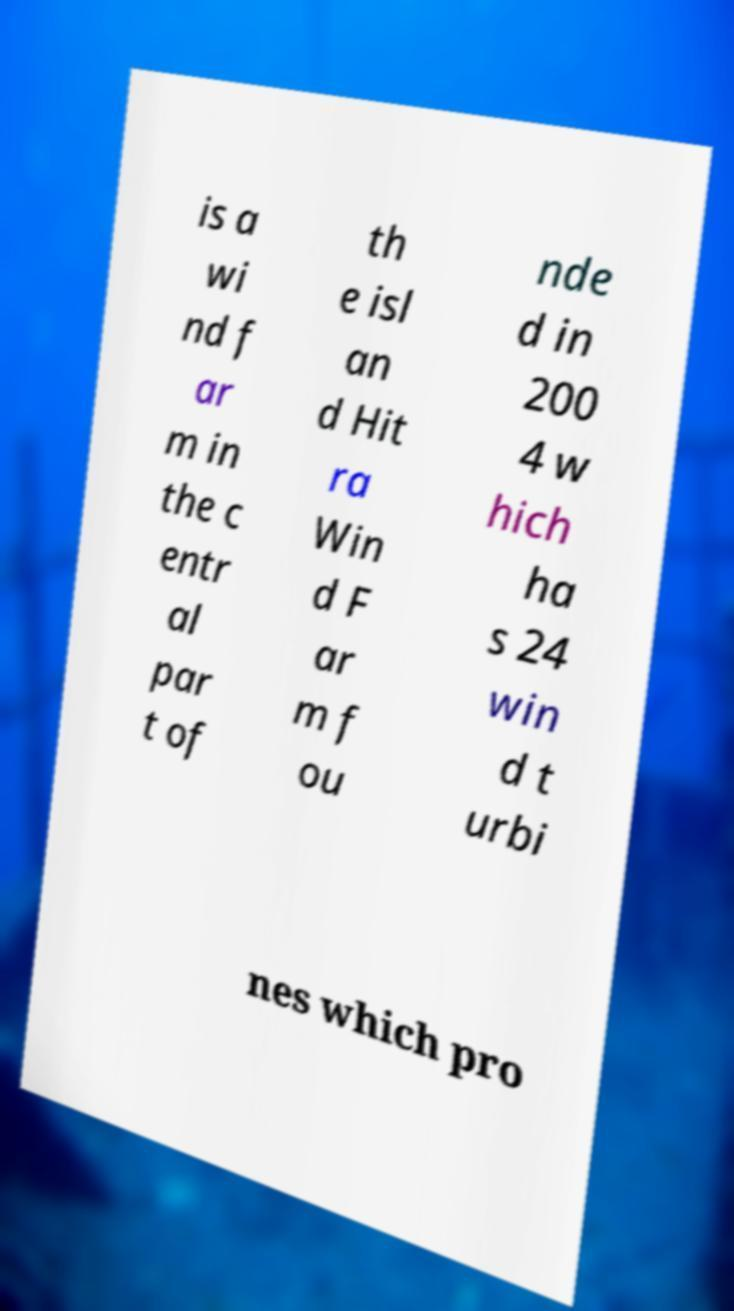Can you accurately transcribe the text from the provided image for me? is a wi nd f ar m in the c entr al par t of th e isl an d Hit ra Win d F ar m f ou nde d in 200 4 w hich ha s 24 win d t urbi nes which pro 